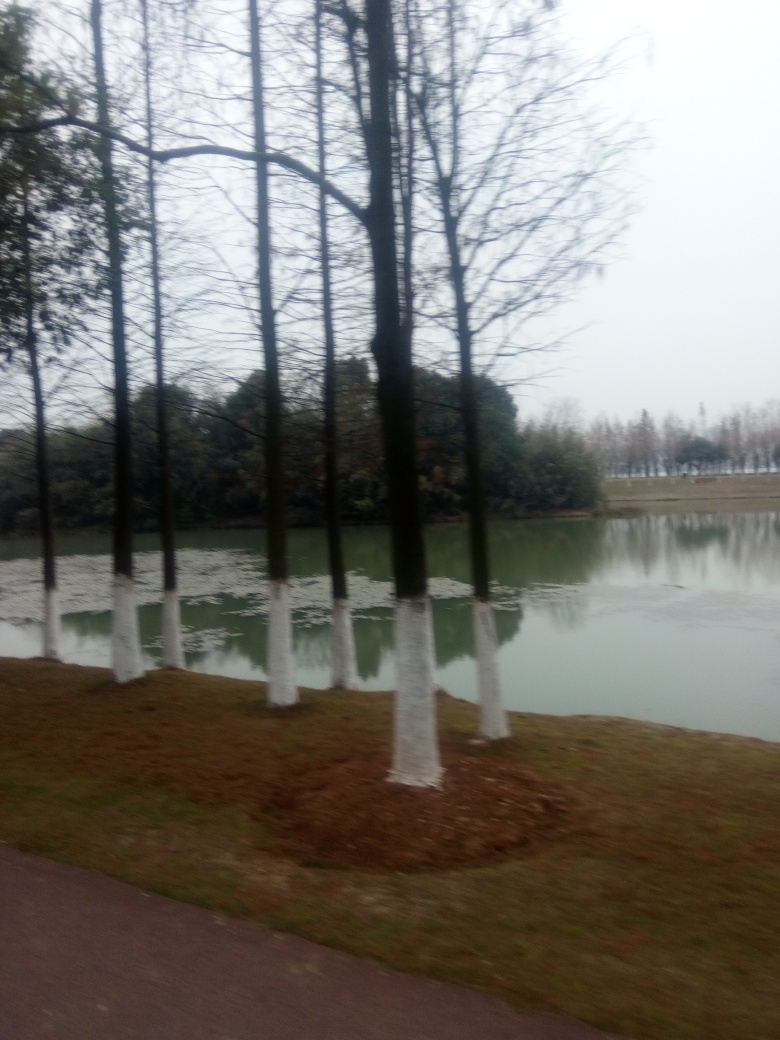What is the weather like in this image? The overcast sky and absence of shadows suggest an overcast or cloudy day, potentially with cooler temperatures. 